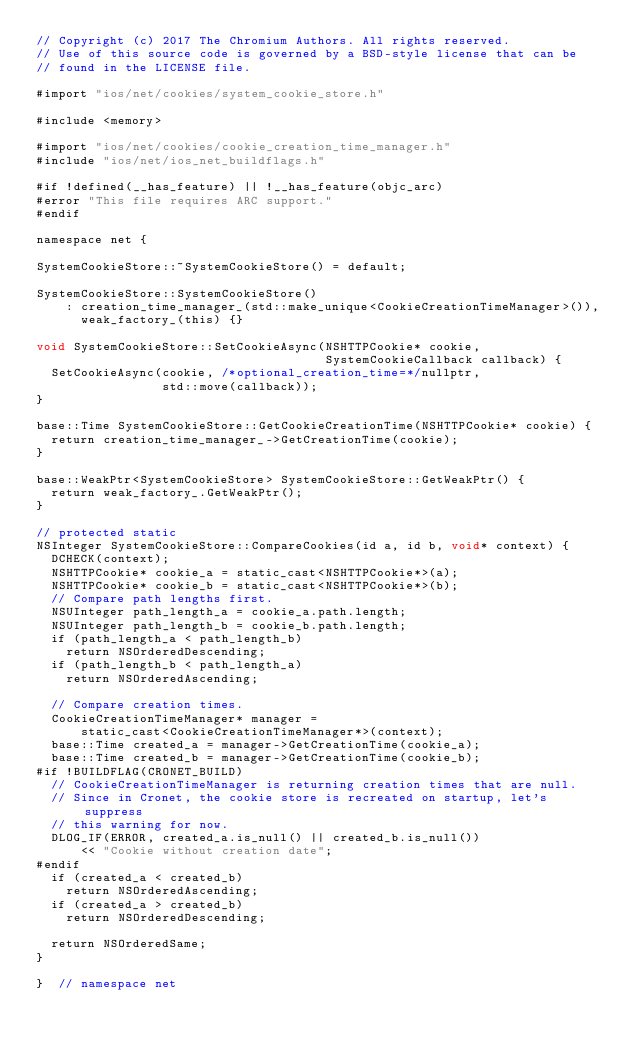Convert code to text. <code><loc_0><loc_0><loc_500><loc_500><_ObjectiveC_>// Copyright (c) 2017 The Chromium Authors. All rights reserved.
// Use of this source code is governed by a BSD-style license that can be
// found in the LICENSE file.

#import "ios/net/cookies/system_cookie_store.h"

#include <memory>

#import "ios/net/cookies/cookie_creation_time_manager.h"
#include "ios/net/ios_net_buildflags.h"

#if !defined(__has_feature) || !__has_feature(objc_arc)
#error "This file requires ARC support."
#endif

namespace net {

SystemCookieStore::~SystemCookieStore() = default;

SystemCookieStore::SystemCookieStore()
    : creation_time_manager_(std::make_unique<CookieCreationTimeManager>()),
      weak_factory_(this) {}

void SystemCookieStore::SetCookieAsync(NSHTTPCookie* cookie,
                                       SystemCookieCallback callback) {
  SetCookieAsync(cookie, /*optional_creation_time=*/nullptr,
                 std::move(callback));
}

base::Time SystemCookieStore::GetCookieCreationTime(NSHTTPCookie* cookie) {
  return creation_time_manager_->GetCreationTime(cookie);
}

base::WeakPtr<SystemCookieStore> SystemCookieStore::GetWeakPtr() {
  return weak_factory_.GetWeakPtr();
}

// protected static
NSInteger SystemCookieStore::CompareCookies(id a, id b, void* context) {
  DCHECK(context);
  NSHTTPCookie* cookie_a = static_cast<NSHTTPCookie*>(a);
  NSHTTPCookie* cookie_b = static_cast<NSHTTPCookie*>(b);
  // Compare path lengths first.
  NSUInteger path_length_a = cookie_a.path.length;
  NSUInteger path_length_b = cookie_b.path.length;
  if (path_length_a < path_length_b)
    return NSOrderedDescending;
  if (path_length_b < path_length_a)
    return NSOrderedAscending;

  // Compare creation times.
  CookieCreationTimeManager* manager =
      static_cast<CookieCreationTimeManager*>(context);
  base::Time created_a = manager->GetCreationTime(cookie_a);
  base::Time created_b = manager->GetCreationTime(cookie_b);
#if !BUILDFLAG(CRONET_BUILD)
  // CookieCreationTimeManager is returning creation times that are null.
  // Since in Cronet, the cookie store is recreated on startup, let's suppress
  // this warning for now.
  DLOG_IF(ERROR, created_a.is_null() || created_b.is_null())
      << "Cookie without creation date";
#endif
  if (created_a < created_b)
    return NSOrderedAscending;
  if (created_a > created_b)
    return NSOrderedDescending;

  return NSOrderedSame;
}

}  // namespace net
</code> 